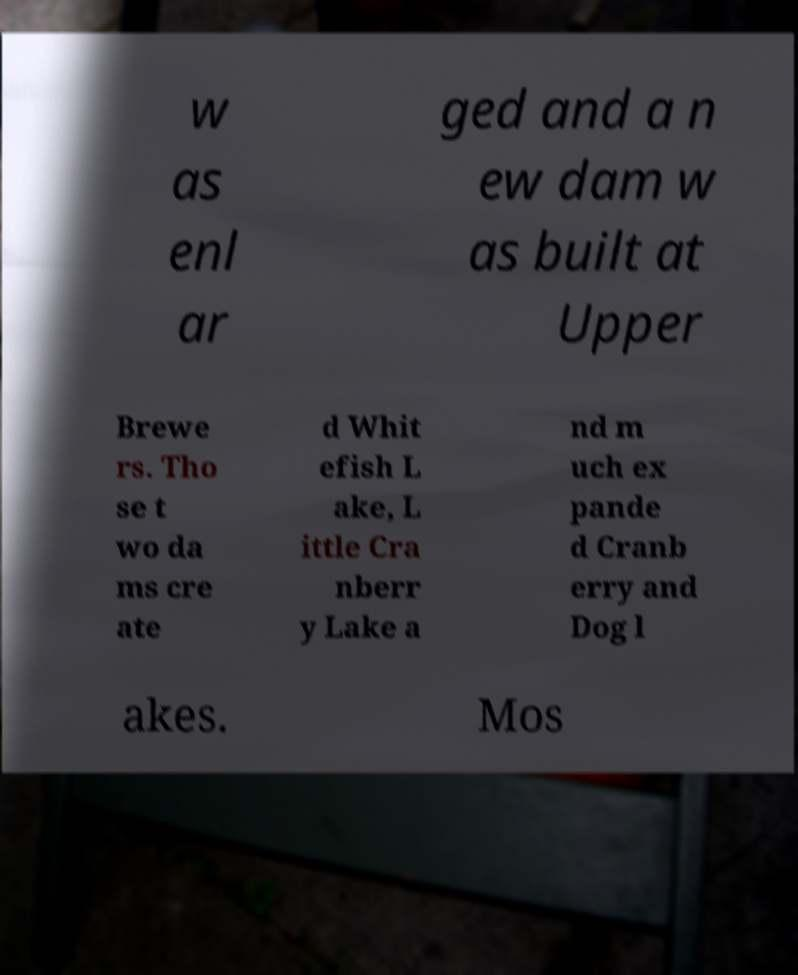Can you accurately transcribe the text from the provided image for me? w as enl ar ged and a n ew dam w as built at Upper Brewe rs. Tho se t wo da ms cre ate d Whit efish L ake, L ittle Cra nberr y Lake a nd m uch ex pande d Cranb erry and Dog l akes. Mos 